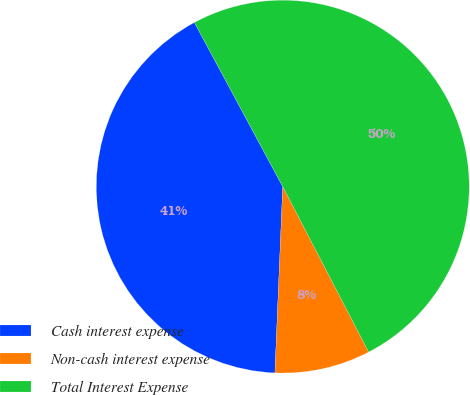Convert chart to OTSL. <chart><loc_0><loc_0><loc_500><loc_500><pie_chart><fcel>Cash interest expense<fcel>Non-cash interest expense<fcel>Total Interest Expense<nl><fcel>41.47%<fcel>8.29%<fcel>50.23%<nl></chart> 